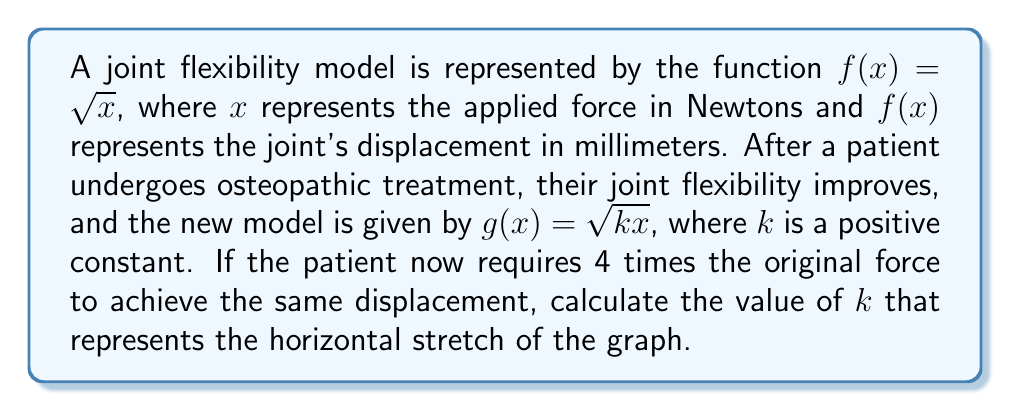Give your solution to this math problem. To solve this problem, we need to understand how horizontal stretches affect function graphs and relate this to the given information.

1) The original function is $f(x) = \sqrt{x}$, and the new function is $g(x) = \sqrt{kx}$.

2) A horizontal stretch by a factor of $a$ transforms $f(x)$ to $f(\frac{x}{a})$.

3) In this case, $g(x) = f(\frac{x}{k})$, so $k$ represents the horizontal stretch factor.

4) We're told that the patient now requires 4 times the original force to achieve the same displacement. This means that for any given $y$ value:

   $f(x) = y$ and $g(4x) = y$

5) Let's express this mathematically:

   $\sqrt{x} = \sqrt{k(4x)}$

6) Square both sides:

   $x = k(4x)$

7) Simplify:

   $1 = 4k$

8) Solve for $k$:

   $k = \frac{1}{4}$

Therefore, the horizontal stretch factor is $\frac{1}{4}$, which means the graph is compressed horizontally by a factor of 4.
Answer: $k = \frac{1}{4}$ 